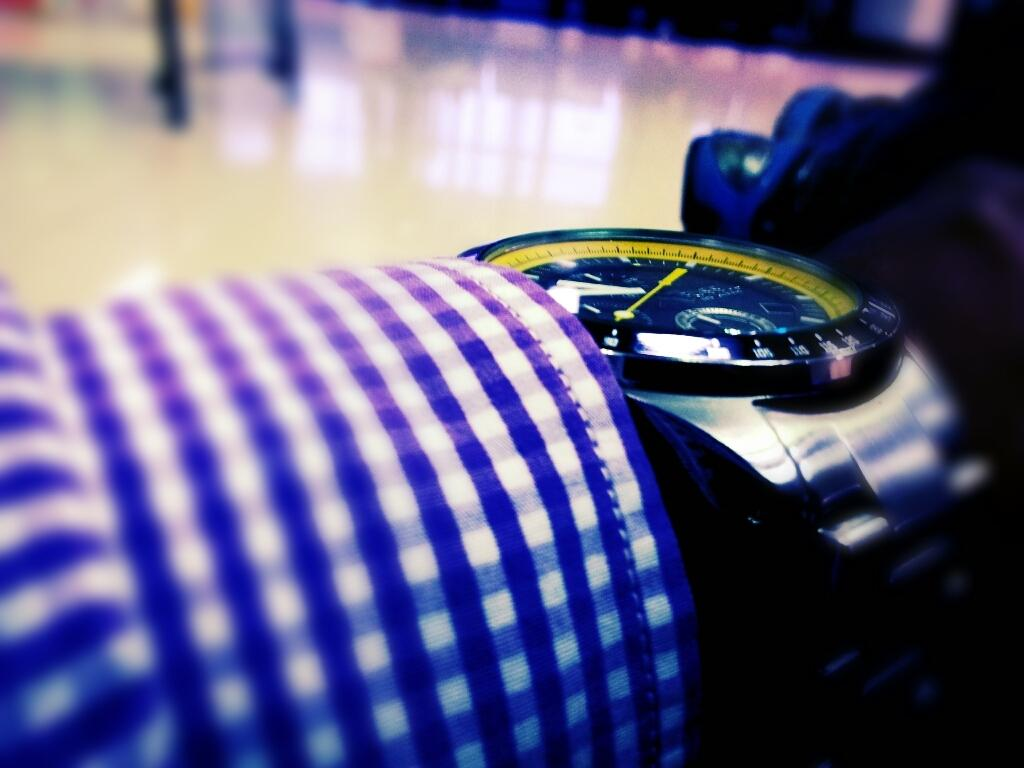What is located in the foreground of the image? There is a watch and a cloth in the foreground of the image. Can you describe the watch in the image? The watch is the main object in the foreground, but no further details about its appearance are provided. What else can be seen in the foreground of the image? Besides the watch, there is also a cloth visible in the foreground. What can be seen in the background of the image? Other objects are visible in the background of the image, but no specific details are provided. Can you tell me how many donkeys are visible in the image? There are no donkeys present in the image. What type of spring is attached to the watch in the image? There is no mention of a spring or any other mechanical component of the watch in the image. 